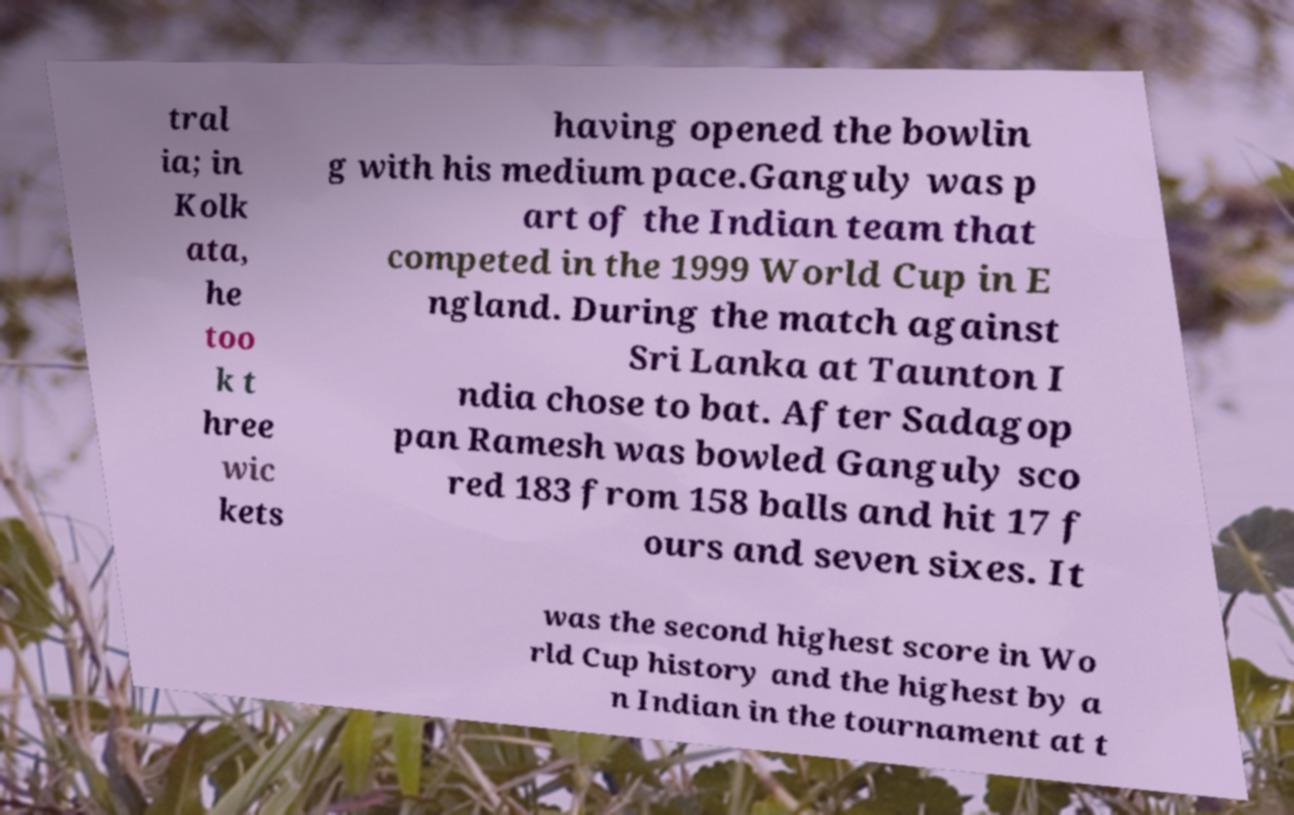Can you read and provide the text displayed in the image?This photo seems to have some interesting text. Can you extract and type it out for me? tral ia; in Kolk ata, he too k t hree wic kets having opened the bowlin g with his medium pace.Ganguly was p art of the Indian team that competed in the 1999 World Cup in E ngland. During the match against Sri Lanka at Taunton I ndia chose to bat. After Sadagop pan Ramesh was bowled Ganguly sco red 183 from 158 balls and hit 17 f ours and seven sixes. It was the second highest score in Wo rld Cup history and the highest by a n Indian in the tournament at t 